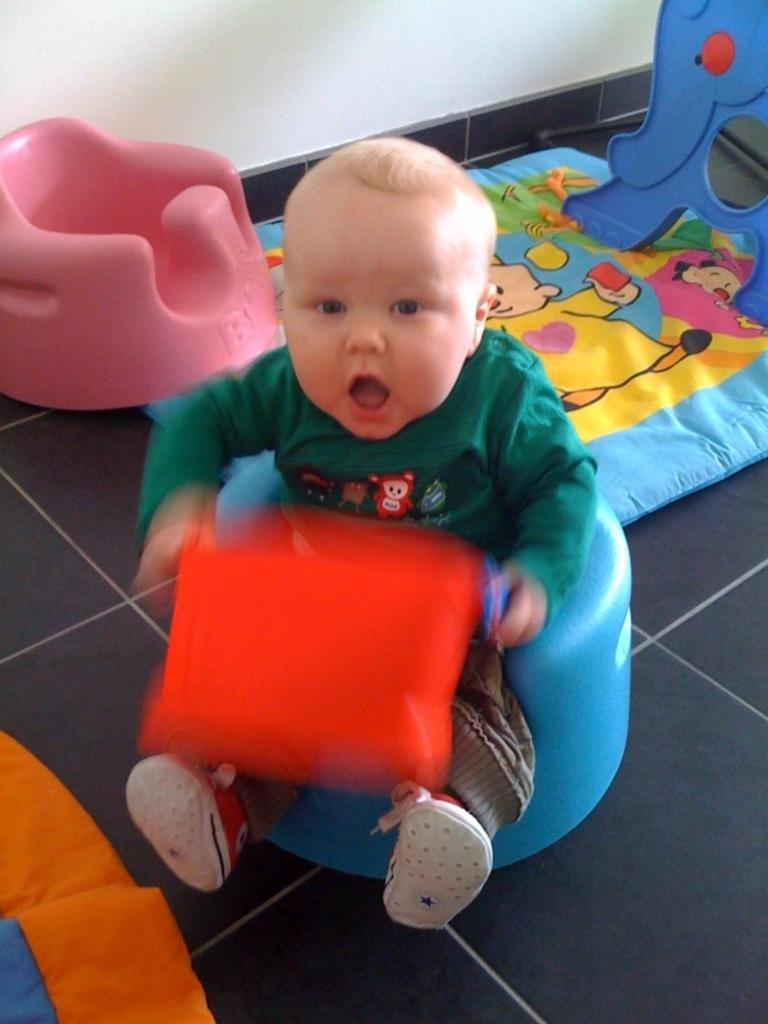What is the main subject of the image? The main subject of the image is a kid. What is the kid doing in the image? The kid is sitting on a stool in the image. What is the kid holding in their hand? The kid is holding something in their hand, but we cannot determine what it is from the image. What color is the dress the kid is wearing? The kid is wearing a green color dress. How many trucks can be seen in the image? There are no trucks present in the image. What type of bells are hanging from the kid's neck in the image? There are no bells visible in the image, and the kid is not wearing any necklaces or accessories. 